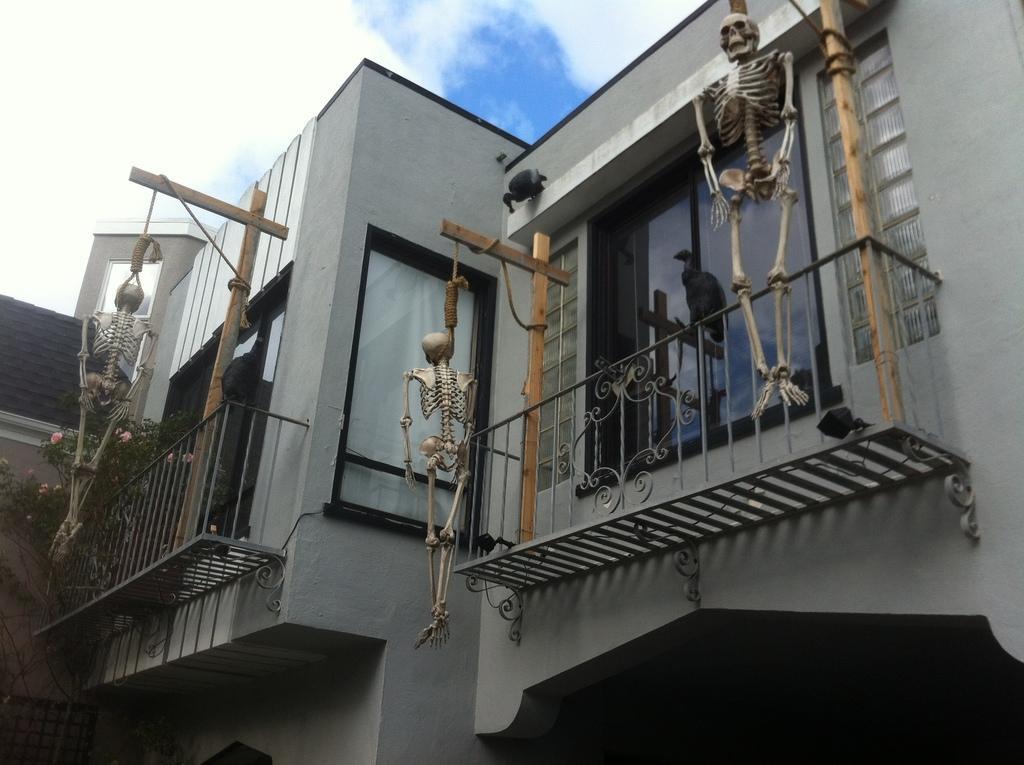In one or two sentences, can you explain what this image depicts? In this picture I can observe a house. There are three skeletons hanged to the poles in this picture. On the left side there are some plants. In the background I can observe some clouds in the sky. 